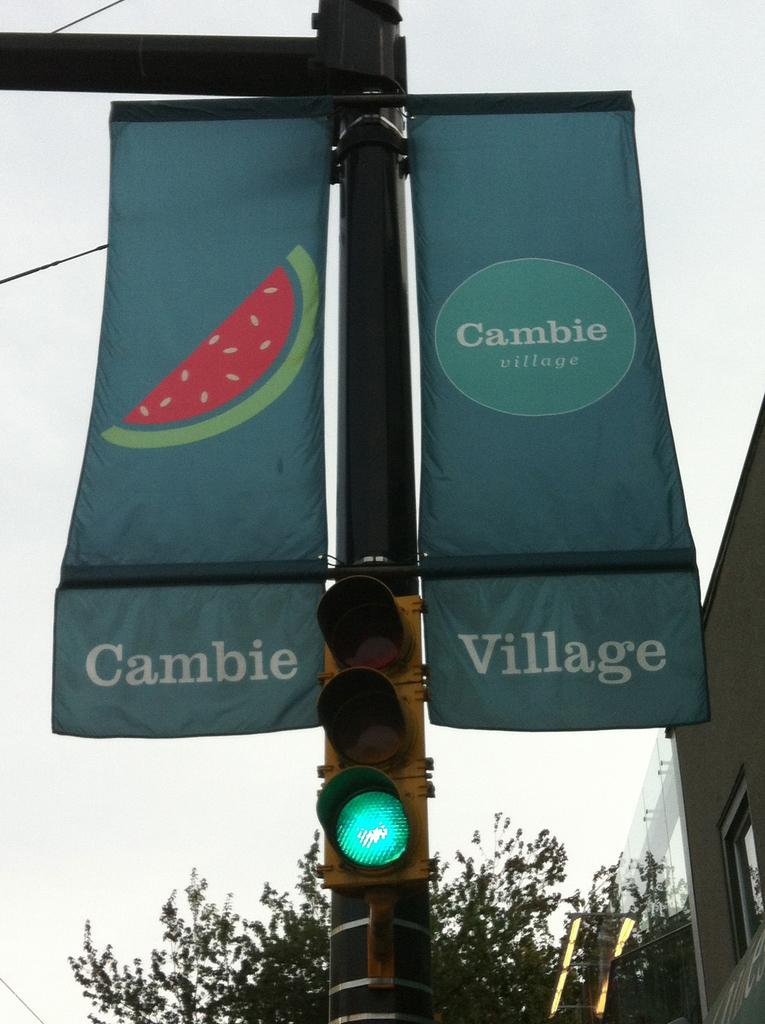<image>
Present a compact description of the photo's key features. Two banners hanging vertically off a post with a green light that states Cambie Village. 